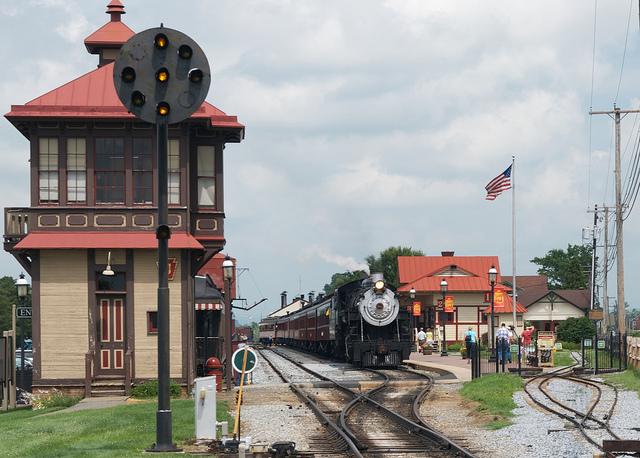What do the three lights indicate?
Answer briefly. Go straight. What country's flag is in this photo?
Concise answer only. United states. Are there people in this photo?
Give a very brief answer. Yes. 